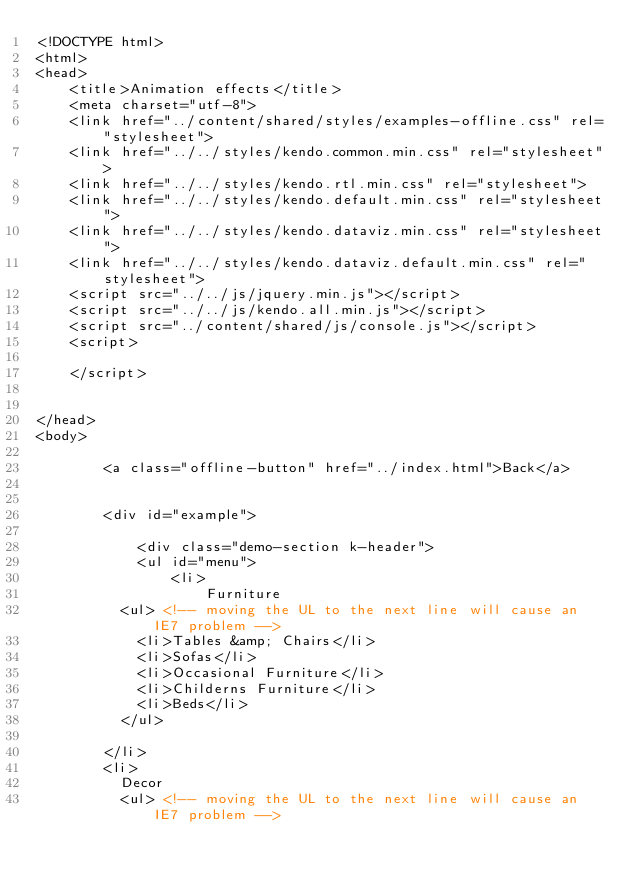Convert code to text. <code><loc_0><loc_0><loc_500><loc_500><_HTML_><!DOCTYPE html>
<html>
<head>
    <title>Animation effects</title>
    <meta charset="utf-8">
    <link href="../content/shared/styles/examples-offline.css" rel="stylesheet">
    <link href="../../styles/kendo.common.min.css" rel="stylesheet">
    <link href="../../styles/kendo.rtl.min.css" rel="stylesheet">
    <link href="../../styles/kendo.default.min.css" rel="stylesheet">
    <link href="../../styles/kendo.dataviz.min.css" rel="stylesheet">
    <link href="../../styles/kendo.dataviz.default.min.css" rel="stylesheet">
    <script src="../../js/jquery.min.js"></script>
    <script src="../../js/kendo.all.min.js"></script>
    <script src="../content/shared/js/console.js"></script>
    <script>
        
    </script>
    
    
</head>
<body>
    
        <a class="offline-button" href="../index.html">Back</a>
    
    
        <div id="example">

            <div class="demo-section k-header">
            <ul id="menu">
                <li>
                    Furniture
					<ul> <!-- moving the UL to the next line will cause an IE7 problem -->
						<li>Tables &amp; Chairs</li>
						<li>Sofas</li>
						<li>Occasional Furniture</li>
						<li>Childerns Furniture</li>
						<li>Beds</li>
					</ul>

				</li>
				<li>
					Decor
					<ul> <!-- moving the UL to the next line will cause an IE7 problem --></code> 